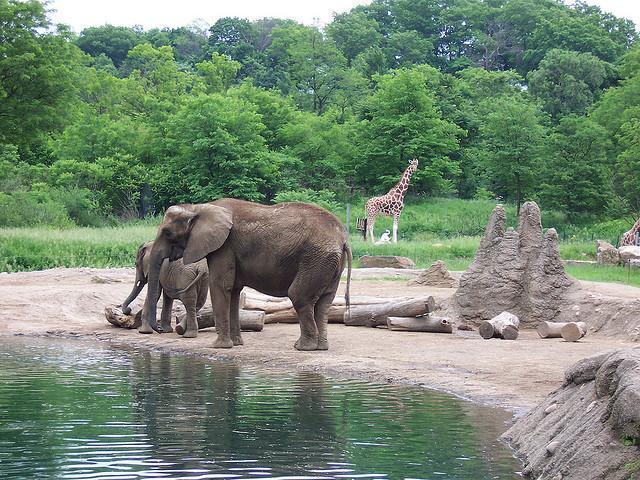How many elephants are in the photo?
Give a very brief answer. 2. How many people are in the foto?
Give a very brief answer. 0. 